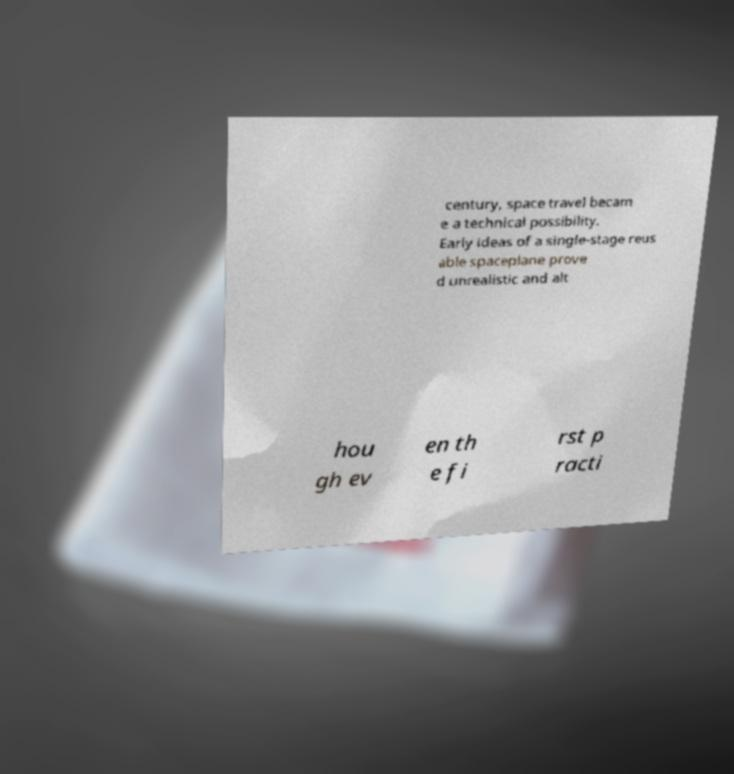Please read and relay the text visible in this image. What does it say? century, space travel becam e a technical possibility. Early ideas of a single-stage reus able spaceplane prove d unrealistic and alt hou gh ev en th e fi rst p racti 